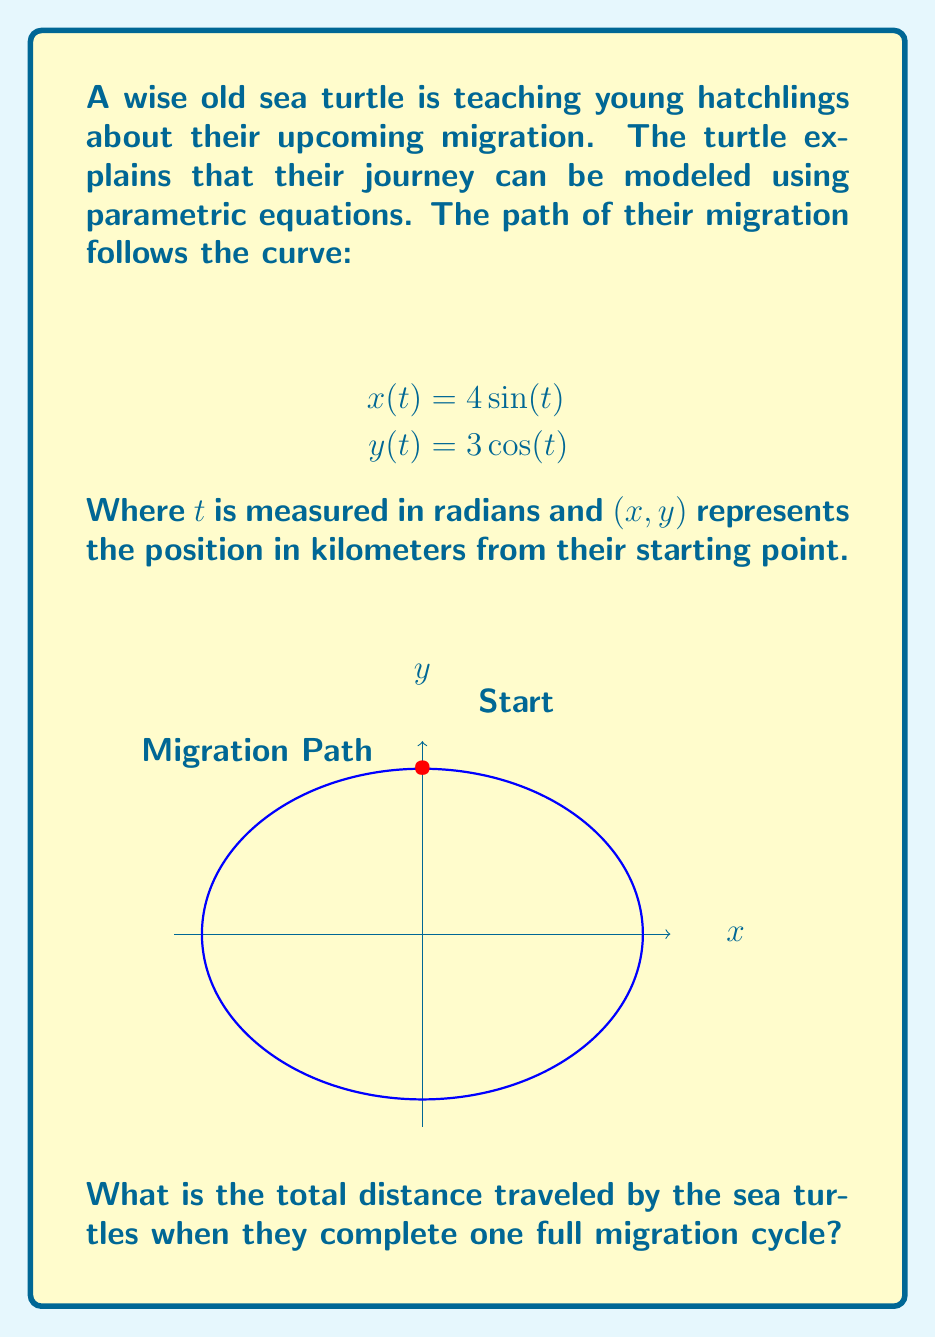Teach me how to tackle this problem. Let's approach this step-by-step:

1) The parametric equations describe an ellipse. To find the distance traveled, we need to calculate the circumference of this ellipse.

2) For an ellipse with semi-major axis $a$ and semi-minor axis $b$, the circumference can be approximated using Ramanujan's formula:

   $$C \approx \pi(a+b)\left(1 + \frac{3h}{10 + \sqrt{4-3h}}\right)$$

   where $h = \frac{(a-b)^2}{(a+b)^2}$

3) In our case, $a = 4$ and $b = 3$ (the coefficients in the parametric equations).

4) Let's calculate $h$:
   
   $$h = \frac{(4-3)^2}{(4+3)^2} = \frac{1}{49} \approx 0.0204$$

5) Now we can substitute into Ramanujan's formula:

   $$C \approx \pi(4+3)\left(1 + \frac{3(0.0204)}{10 + \sqrt{4-3(0.0204)}}\right)$$

6) Simplifying:
   
   $$C \approx 7\pi\left(1 + \frac{0.0612}{10 + \sqrt{3.9388}}\right)$$
   $$C \approx 7\pi(1.00306)$$
   $$C \approx 22.0203$$

Therefore, the total distance traveled is approximately 22.0203 kilometers.
Answer: $22.0203$ km 